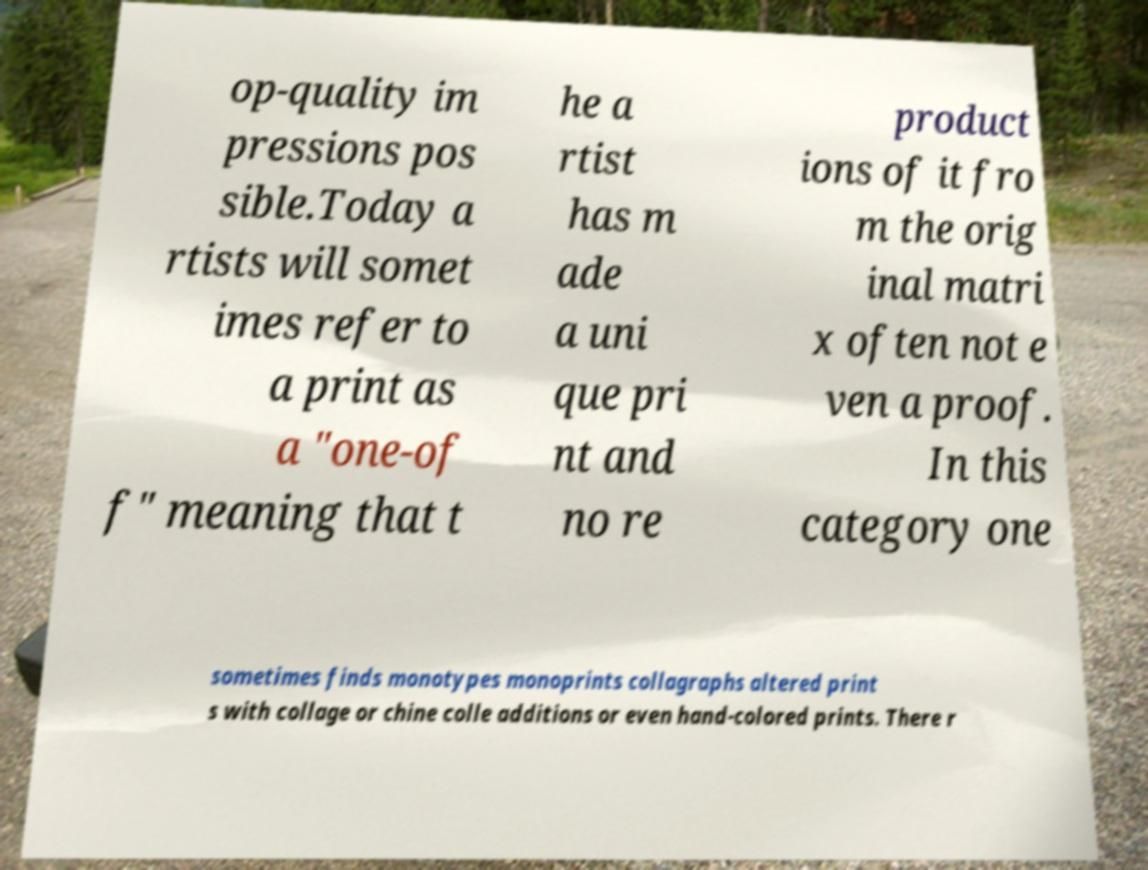Can you read and provide the text displayed in the image?This photo seems to have some interesting text. Can you extract and type it out for me? op-quality im pressions pos sible.Today a rtists will somet imes refer to a print as a "one-of f" meaning that t he a rtist has m ade a uni que pri nt and no re product ions of it fro m the orig inal matri x often not e ven a proof. In this category one sometimes finds monotypes monoprints collagraphs altered print s with collage or chine colle additions or even hand-colored prints. There r 